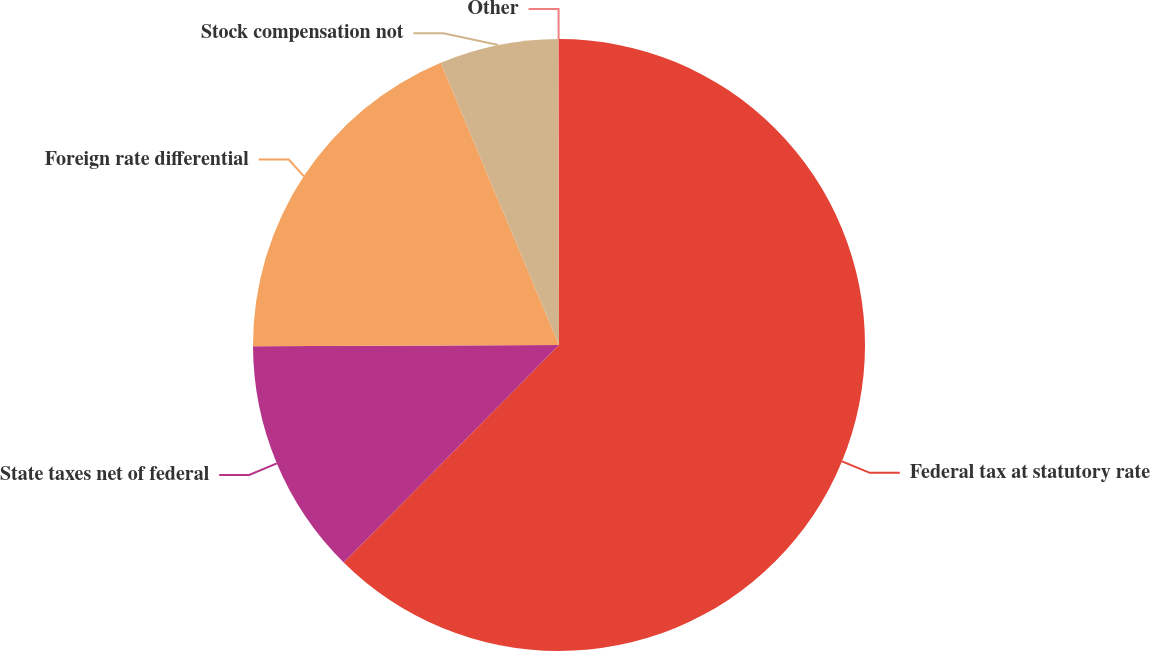<chart> <loc_0><loc_0><loc_500><loc_500><pie_chart><fcel>Federal tax at statutory rate<fcel>State taxes net of federal<fcel>Foreign rate differential<fcel>Stock compensation not<fcel>Other<nl><fcel>62.42%<fcel>12.51%<fcel>18.75%<fcel>6.28%<fcel>0.04%<nl></chart> 